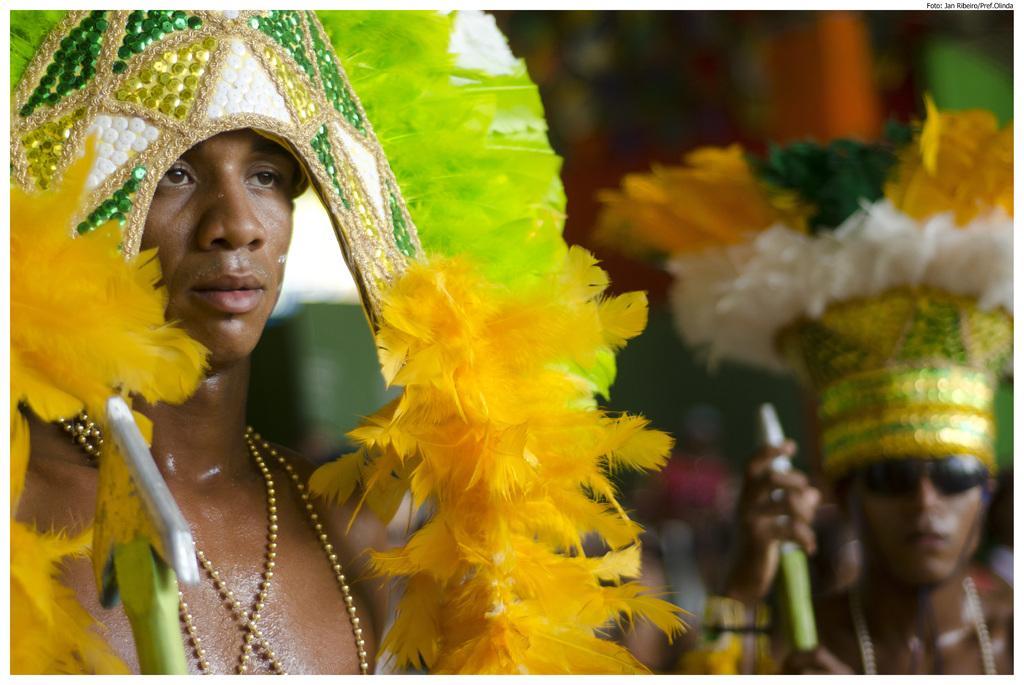How would you summarize this image in a sentence or two? In this picture I can observe a man on the left side. On the right side I can observe another person. The background is blurred. 